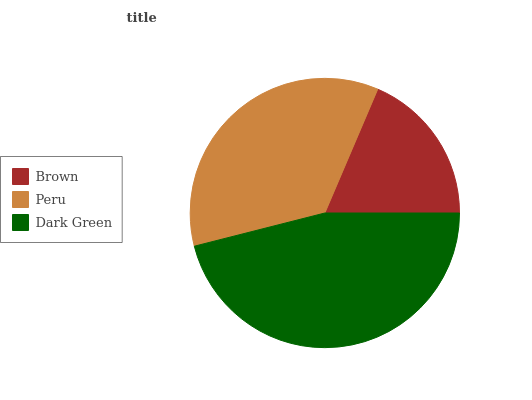Is Brown the minimum?
Answer yes or no. Yes. Is Dark Green the maximum?
Answer yes or no. Yes. Is Peru the minimum?
Answer yes or no. No. Is Peru the maximum?
Answer yes or no. No. Is Peru greater than Brown?
Answer yes or no. Yes. Is Brown less than Peru?
Answer yes or no. Yes. Is Brown greater than Peru?
Answer yes or no. No. Is Peru less than Brown?
Answer yes or no. No. Is Peru the high median?
Answer yes or no. Yes. Is Peru the low median?
Answer yes or no. Yes. Is Dark Green the high median?
Answer yes or no. No. Is Dark Green the low median?
Answer yes or no. No. 